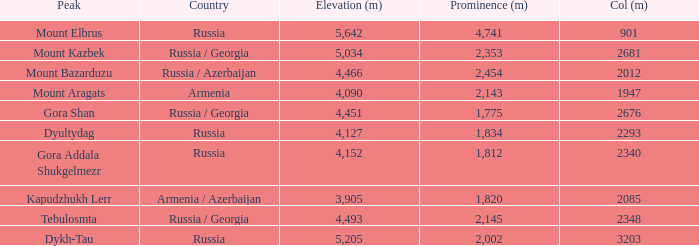What is the Elevation (m) of the Peak with a Prominence (m) larger than 2,143 and Col (m) of 2012? 4466.0. 